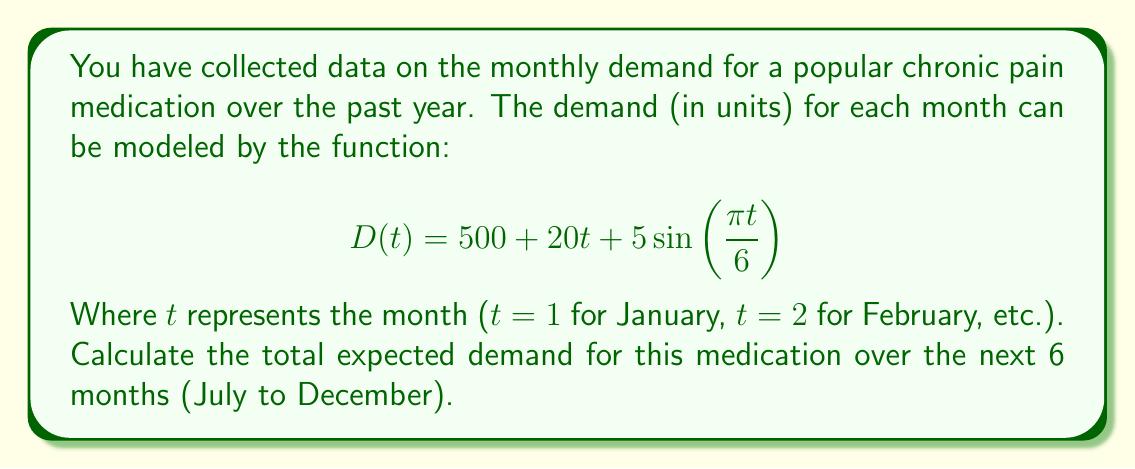Can you answer this question? To solve this problem, we need to follow these steps:

1) Identify the values of $t$ for July to December:
   July (t = 7), August (t = 8), September (t = 9), October (t = 10), November (t = 11), December (t = 12)

2) Calculate the demand for each month using the given function:
   $$ D(t) = 500 + 20t + 5\sin(\frac{\pi t}{6}) $$

3) Sum up the demands for all 6 months.

Let's calculate for each month:

July (t = 7):
$$ D(7) = 500 + 20(7) + 5\sin(\frac{7\pi}{6}) = 500 + 140 + 5(0.5) = 642.5 $$

August (t = 8):
$$ D(8) = 500 + 20(8) + 5\sin(\frac{8\pi}{6}) = 500 + 160 + 5(\frac{\sqrt{3}}{2}) = 664.33 $$

September (t = 9):
$$ D(9) = 500 + 20(9) + 5\sin(\frac{9\pi}{6}) = 500 + 180 + 5(1) = 685 $$

October (t = 10):
$$ D(10) = 500 + 20(10) + 5\sin(\frac{10\pi}{6}) = 500 + 200 + 5(\frac{\sqrt{3}}{2}) = 704.33 $$

November (t = 11):
$$ D(11) = 500 + 20(11) + 5\sin(\frac{11\pi}{6}) = 500 + 220 + 5(0.5) = 722.5 $$

December (t = 12):
$$ D(12) = 500 + 20(12) + 5\sin(\frac{12\pi}{6}) = 500 + 240 + 5(0) = 740 $$

Now, we sum up all these values:
$$ 642.5 + 664.33 + 685 + 704.33 + 722.5 + 740 = 4158.66 $$

Therefore, the total expected demand over the next 6 months is approximately 4159 units.
Answer: 4159 units 